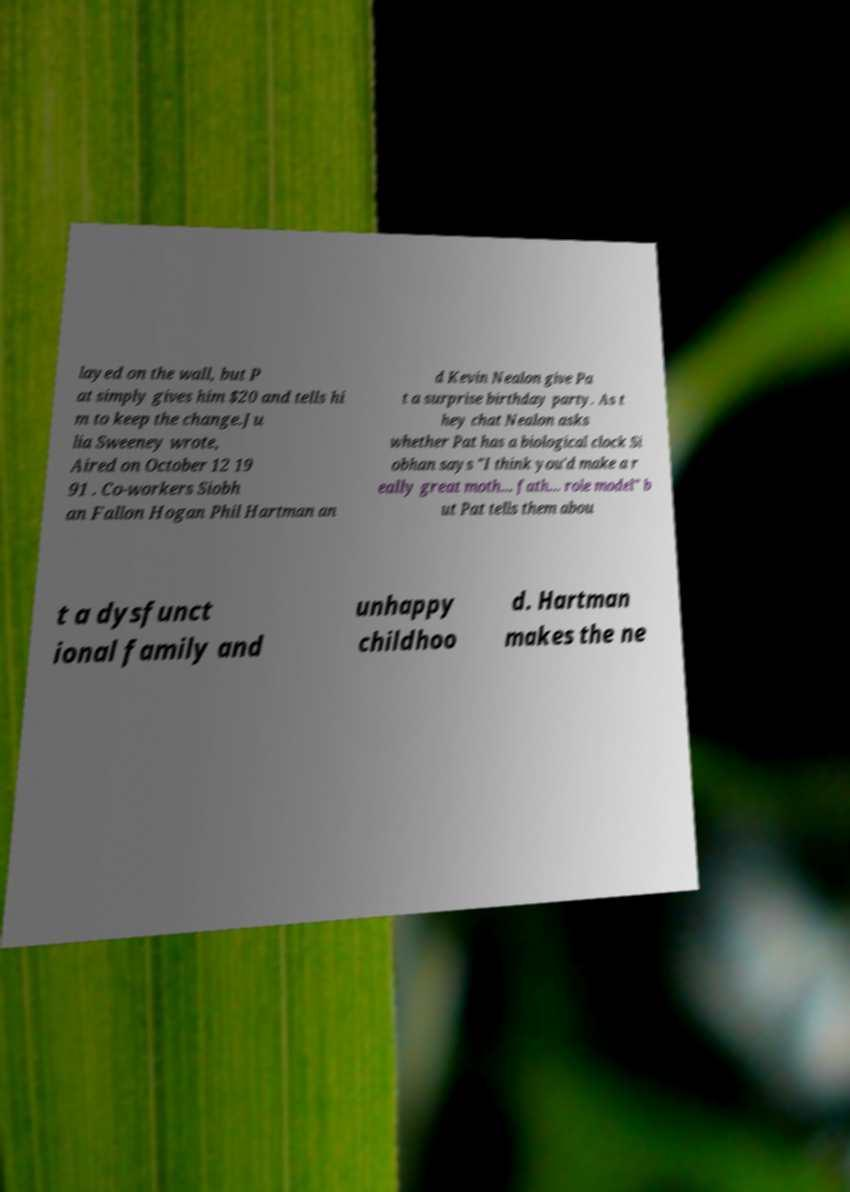Could you extract and type out the text from this image? layed on the wall, but P at simply gives him $20 and tells hi m to keep the change.Ju lia Sweeney wrote, Aired on October 12 19 91 . Co-workers Siobh an Fallon Hogan Phil Hartman an d Kevin Nealon give Pa t a surprise birthday party. As t hey chat Nealon asks whether Pat has a biological clock Si obhan says "I think you'd make a r eally great moth... fath... role model" b ut Pat tells them abou t a dysfunct ional family and unhappy childhoo d. Hartman makes the ne 